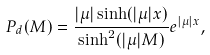<formula> <loc_0><loc_0><loc_500><loc_500>P _ { d } ( M ) = \frac { | \mu | \sinh ( | \mu | x ) } { \sinh ^ { 2 } ( | \mu | M ) } e ^ { | \mu | x } ,</formula> 